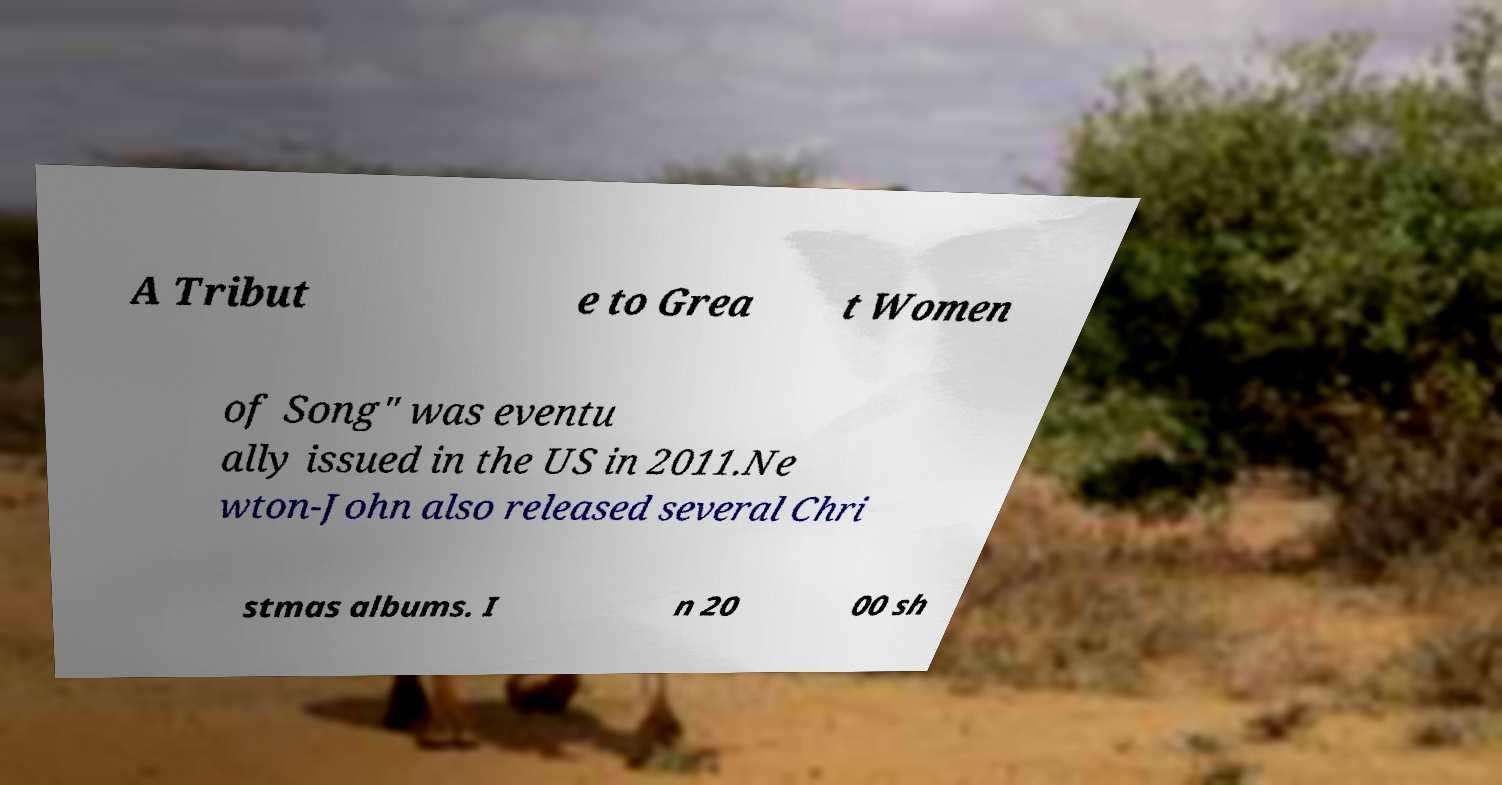For documentation purposes, I need the text within this image transcribed. Could you provide that? A Tribut e to Grea t Women of Song" was eventu ally issued in the US in 2011.Ne wton-John also released several Chri stmas albums. I n 20 00 sh 